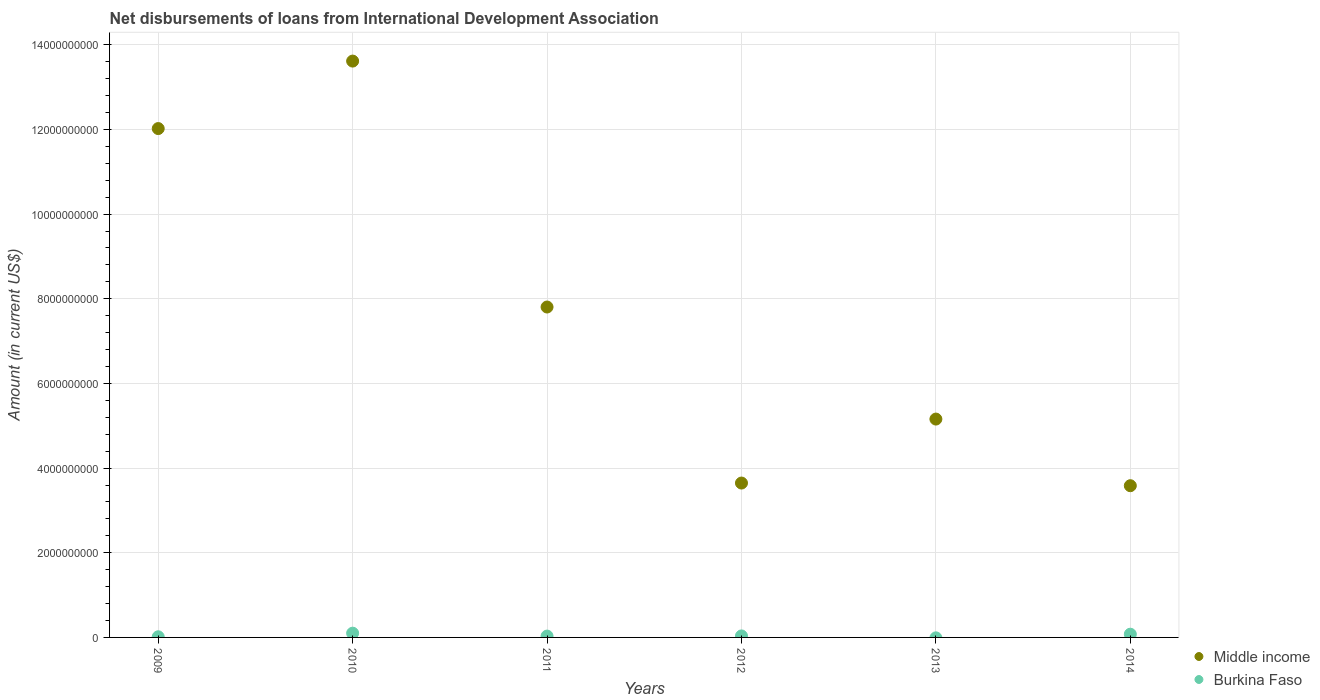Is the number of dotlines equal to the number of legend labels?
Your answer should be very brief. No. What is the amount of loans disbursed in Middle income in 2014?
Keep it short and to the point. 3.58e+09. Across all years, what is the maximum amount of loans disbursed in Burkina Faso?
Your answer should be very brief. 1.00e+08. Across all years, what is the minimum amount of loans disbursed in Middle income?
Keep it short and to the point. 3.58e+09. In which year was the amount of loans disbursed in Middle income maximum?
Provide a succinct answer. 2010. What is the total amount of loans disbursed in Burkina Faso in the graph?
Your response must be concise. 2.59e+08. What is the difference between the amount of loans disbursed in Middle income in 2010 and that in 2012?
Your answer should be very brief. 9.97e+09. What is the difference between the amount of loans disbursed in Burkina Faso in 2009 and the amount of loans disbursed in Middle income in 2010?
Offer a very short reply. -1.36e+1. What is the average amount of loans disbursed in Middle income per year?
Keep it short and to the point. 7.64e+09. In the year 2009, what is the difference between the amount of loans disbursed in Middle income and amount of loans disbursed in Burkina Faso?
Your response must be concise. 1.20e+1. What is the ratio of the amount of loans disbursed in Burkina Faso in 2009 to that in 2010?
Give a very brief answer. 0.15. What is the difference between the highest and the second highest amount of loans disbursed in Burkina Faso?
Your answer should be very brief. 2.44e+07. What is the difference between the highest and the lowest amount of loans disbursed in Burkina Faso?
Keep it short and to the point. 1.00e+08. Is the sum of the amount of loans disbursed in Burkina Faso in 2009 and 2010 greater than the maximum amount of loans disbursed in Middle income across all years?
Your answer should be very brief. No. Does the amount of loans disbursed in Middle income monotonically increase over the years?
Provide a short and direct response. No. Is the amount of loans disbursed in Burkina Faso strictly greater than the amount of loans disbursed in Middle income over the years?
Ensure brevity in your answer.  No. Is the amount of loans disbursed in Burkina Faso strictly less than the amount of loans disbursed in Middle income over the years?
Provide a succinct answer. Yes. What is the difference between two consecutive major ticks on the Y-axis?
Offer a very short reply. 2.00e+09. Are the values on the major ticks of Y-axis written in scientific E-notation?
Provide a short and direct response. No. Does the graph contain any zero values?
Your answer should be compact. Yes. Does the graph contain grids?
Offer a very short reply. Yes. Where does the legend appear in the graph?
Ensure brevity in your answer.  Bottom right. What is the title of the graph?
Your answer should be compact. Net disbursements of loans from International Development Association. Does "Yemen, Rep." appear as one of the legend labels in the graph?
Provide a succinct answer. No. What is the Amount (in current US$) in Middle income in 2009?
Provide a succinct answer. 1.20e+1. What is the Amount (in current US$) in Burkina Faso in 2009?
Keep it short and to the point. 1.51e+07. What is the Amount (in current US$) in Middle income in 2010?
Your response must be concise. 1.36e+1. What is the Amount (in current US$) in Burkina Faso in 2010?
Provide a short and direct response. 1.00e+08. What is the Amount (in current US$) of Middle income in 2011?
Offer a terse response. 7.81e+09. What is the Amount (in current US$) in Burkina Faso in 2011?
Your response must be concise. 3.15e+07. What is the Amount (in current US$) of Middle income in 2012?
Your answer should be compact. 3.65e+09. What is the Amount (in current US$) of Burkina Faso in 2012?
Give a very brief answer. 3.53e+07. What is the Amount (in current US$) of Middle income in 2013?
Make the answer very short. 5.16e+09. What is the Amount (in current US$) of Middle income in 2014?
Ensure brevity in your answer.  3.58e+09. What is the Amount (in current US$) in Burkina Faso in 2014?
Your answer should be compact. 7.61e+07. Across all years, what is the maximum Amount (in current US$) of Middle income?
Ensure brevity in your answer.  1.36e+1. Across all years, what is the maximum Amount (in current US$) of Burkina Faso?
Offer a terse response. 1.00e+08. Across all years, what is the minimum Amount (in current US$) of Middle income?
Ensure brevity in your answer.  3.58e+09. What is the total Amount (in current US$) in Middle income in the graph?
Make the answer very short. 4.58e+1. What is the total Amount (in current US$) of Burkina Faso in the graph?
Your response must be concise. 2.59e+08. What is the difference between the Amount (in current US$) of Middle income in 2009 and that in 2010?
Provide a short and direct response. -1.59e+09. What is the difference between the Amount (in current US$) of Burkina Faso in 2009 and that in 2010?
Offer a very short reply. -8.53e+07. What is the difference between the Amount (in current US$) in Middle income in 2009 and that in 2011?
Your answer should be compact. 4.22e+09. What is the difference between the Amount (in current US$) in Burkina Faso in 2009 and that in 2011?
Offer a terse response. -1.64e+07. What is the difference between the Amount (in current US$) in Middle income in 2009 and that in 2012?
Your response must be concise. 8.37e+09. What is the difference between the Amount (in current US$) of Burkina Faso in 2009 and that in 2012?
Your answer should be compact. -2.02e+07. What is the difference between the Amount (in current US$) in Middle income in 2009 and that in 2013?
Your answer should be compact. 6.86e+09. What is the difference between the Amount (in current US$) in Middle income in 2009 and that in 2014?
Your answer should be very brief. 8.44e+09. What is the difference between the Amount (in current US$) of Burkina Faso in 2009 and that in 2014?
Your answer should be very brief. -6.09e+07. What is the difference between the Amount (in current US$) in Middle income in 2010 and that in 2011?
Your answer should be very brief. 5.81e+09. What is the difference between the Amount (in current US$) of Burkina Faso in 2010 and that in 2011?
Ensure brevity in your answer.  6.89e+07. What is the difference between the Amount (in current US$) of Middle income in 2010 and that in 2012?
Provide a succinct answer. 9.97e+09. What is the difference between the Amount (in current US$) in Burkina Faso in 2010 and that in 2012?
Your answer should be very brief. 6.51e+07. What is the difference between the Amount (in current US$) in Middle income in 2010 and that in 2013?
Your response must be concise. 8.46e+09. What is the difference between the Amount (in current US$) of Middle income in 2010 and that in 2014?
Your answer should be compact. 1.00e+1. What is the difference between the Amount (in current US$) of Burkina Faso in 2010 and that in 2014?
Your answer should be compact. 2.44e+07. What is the difference between the Amount (in current US$) of Middle income in 2011 and that in 2012?
Your response must be concise. 4.16e+09. What is the difference between the Amount (in current US$) of Burkina Faso in 2011 and that in 2012?
Ensure brevity in your answer.  -3.79e+06. What is the difference between the Amount (in current US$) of Middle income in 2011 and that in 2013?
Make the answer very short. 2.65e+09. What is the difference between the Amount (in current US$) in Middle income in 2011 and that in 2014?
Your answer should be compact. 4.22e+09. What is the difference between the Amount (in current US$) of Burkina Faso in 2011 and that in 2014?
Make the answer very short. -4.45e+07. What is the difference between the Amount (in current US$) of Middle income in 2012 and that in 2013?
Give a very brief answer. -1.51e+09. What is the difference between the Amount (in current US$) in Middle income in 2012 and that in 2014?
Offer a terse response. 6.28e+07. What is the difference between the Amount (in current US$) in Burkina Faso in 2012 and that in 2014?
Make the answer very short. -4.07e+07. What is the difference between the Amount (in current US$) of Middle income in 2013 and that in 2014?
Your answer should be compact. 1.57e+09. What is the difference between the Amount (in current US$) in Middle income in 2009 and the Amount (in current US$) in Burkina Faso in 2010?
Your response must be concise. 1.19e+1. What is the difference between the Amount (in current US$) in Middle income in 2009 and the Amount (in current US$) in Burkina Faso in 2011?
Ensure brevity in your answer.  1.20e+1. What is the difference between the Amount (in current US$) of Middle income in 2009 and the Amount (in current US$) of Burkina Faso in 2012?
Give a very brief answer. 1.20e+1. What is the difference between the Amount (in current US$) in Middle income in 2009 and the Amount (in current US$) in Burkina Faso in 2014?
Make the answer very short. 1.19e+1. What is the difference between the Amount (in current US$) in Middle income in 2010 and the Amount (in current US$) in Burkina Faso in 2011?
Provide a short and direct response. 1.36e+1. What is the difference between the Amount (in current US$) in Middle income in 2010 and the Amount (in current US$) in Burkina Faso in 2012?
Offer a terse response. 1.36e+1. What is the difference between the Amount (in current US$) in Middle income in 2010 and the Amount (in current US$) in Burkina Faso in 2014?
Ensure brevity in your answer.  1.35e+1. What is the difference between the Amount (in current US$) in Middle income in 2011 and the Amount (in current US$) in Burkina Faso in 2012?
Your answer should be very brief. 7.77e+09. What is the difference between the Amount (in current US$) in Middle income in 2011 and the Amount (in current US$) in Burkina Faso in 2014?
Your answer should be compact. 7.73e+09. What is the difference between the Amount (in current US$) of Middle income in 2012 and the Amount (in current US$) of Burkina Faso in 2014?
Your answer should be compact. 3.57e+09. What is the difference between the Amount (in current US$) of Middle income in 2013 and the Amount (in current US$) of Burkina Faso in 2014?
Your answer should be compact. 5.08e+09. What is the average Amount (in current US$) in Middle income per year?
Provide a short and direct response. 7.64e+09. What is the average Amount (in current US$) of Burkina Faso per year?
Offer a terse response. 4.31e+07. In the year 2009, what is the difference between the Amount (in current US$) of Middle income and Amount (in current US$) of Burkina Faso?
Provide a short and direct response. 1.20e+1. In the year 2010, what is the difference between the Amount (in current US$) in Middle income and Amount (in current US$) in Burkina Faso?
Provide a succinct answer. 1.35e+1. In the year 2011, what is the difference between the Amount (in current US$) of Middle income and Amount (in current US$) of Burkina Faso?
Your response must be concise. 7.77e+09. In the year 2012, what is the difference between the Amount (in current US$) in Middle income and Amount (in current US$) in Burkina Faso?
Offer a terse response. 3.61e+09. In the year 2014, what is the difference between the Amount (in current US$) of Middle income and Amount (in current US$) of Burkina Faso?
Provide a succinct answer. 3.51e+09. What is the ratio of the Amount (in current US$) in Middle income in 2009 to that in 2010?
Keep it short and to the point. 0.88. What is the ratio of the Amount (in current US$) in Burkina Faso in 2009 to that in 2010?
Your answer should be compact. 0.15. What is the ratio of the Amount (in current US$) in Middle income in 2009 to that in 2011?
Provide a succinct answer. 1.54. What is the ratio of the Amount (in current US$) of Burkina Faso in 2009 to that in 2011?
Your answer should be compact. 0.48. What is the ratio of the Amount (in current US$) of Middle income in 2009 to that in 2012?
Offer a very short reply. 3.3. What is the ratio of the Amount (in current US$) of Burkina Faso in 2009 to that in 2012?
Make the answer very short. 0.43. What is the ratio of the Amount (in current US$) of Middle income in 2009 to that in 2013?
Offer a terse response. 2.33. What is the ratio of the Amount (in current US$) of Middle income in 2009 to that in 2014?
Provide a short and direct response. 3.35. What is the ratio of the Amount (in current US$) of Burkina Faso in 2009 to that in 2014?
Keep it short and to the point. 0.2. What is the ratio of the Amount (in current US$) of Middle income in 2010 to that in 2011?
Make the answer very short. 1.74. What is the ratio of the Amount (in current US$) in Burkina Faso in 2010 to that in 2011?
Provide a succinct answer. 3.18. What is the ratio of the Amount (in current US$) of Middle income in 2010 to that in 2012?
Provide a succinct answer. 3.73. What is the ratio of the Amount (in current US$) of Burkina Faso in 2010 to that in 2012?
Provide a succinct answer. 2.84. What is the ratio of the Amount (in current US$) of Middle income in 2010 to that in 2013?
Provide a succinct answer. 2.64. What is the ratio of the Amount (in current US$) in Middle income in 2010 to that in 2014?
Offer a very short reply. 3.8. What is the ratio of the Amount (in current US$) in Burkina Faso in 2010 to that in 2014?
Your answer should be very brief. 1.32. What is the ratio of the Amount (in current US$) in Middle income in 2011 to that in 2012?
Provide a succinct answer. 2.14. What is the ratio of the Amount (in current US$) of Burkina Faso in 2011 to that in 2012?
Give a very brief answer. 0.89. What is the ratio of the Amount (in current US$) of Middle income in 2011 to that in 2013?
Offer a very short reply. 1.51. What is the ratio of the Amount (in current US$) of Middle income in 2011 to that in 2014?
Provide a short and direct response. 2.18. What is the ratio of the Amount (in current US$) of Burkina Faso in 2011 to that in 2014?
Make the answer very short. 0.41. What is the ratio of the Amount (in current US$) in Middle income in 2012 to that in 2013?
Offer a very short reply. 0.71. What is the ratio of the Amount (in current US$) of Middle income in 2012 to that in 2014?
Offer a very short reply. 1.02. What is the ratio of the Amount (in current US$) in Burkina Faso in 2012 to that in 2014?
Make the answer very short. 0.46. What is the ratio of the Amount (in current US$) in Middle income in 2013 to that in 2014?
Your answer should be compact. 1.44. What is the difference between the highest and the second highest Amount (in current US$) in Middle income?
Give a very brief answer. 1.59e+09. What is the difference between the highest and the second highest Amount (in current US$) of Burkina Faso?
Give a very brief answer. 2.44e+07. What is the difference between the highest and the lowest Amount (in current US$) in Middle income?
Keep it short and to the point. 1.00e+1. What is the difference between the highest and the lowest Amount (in current US$) in Burkina Faso?
Offer a terse response. 1.00e+08. 